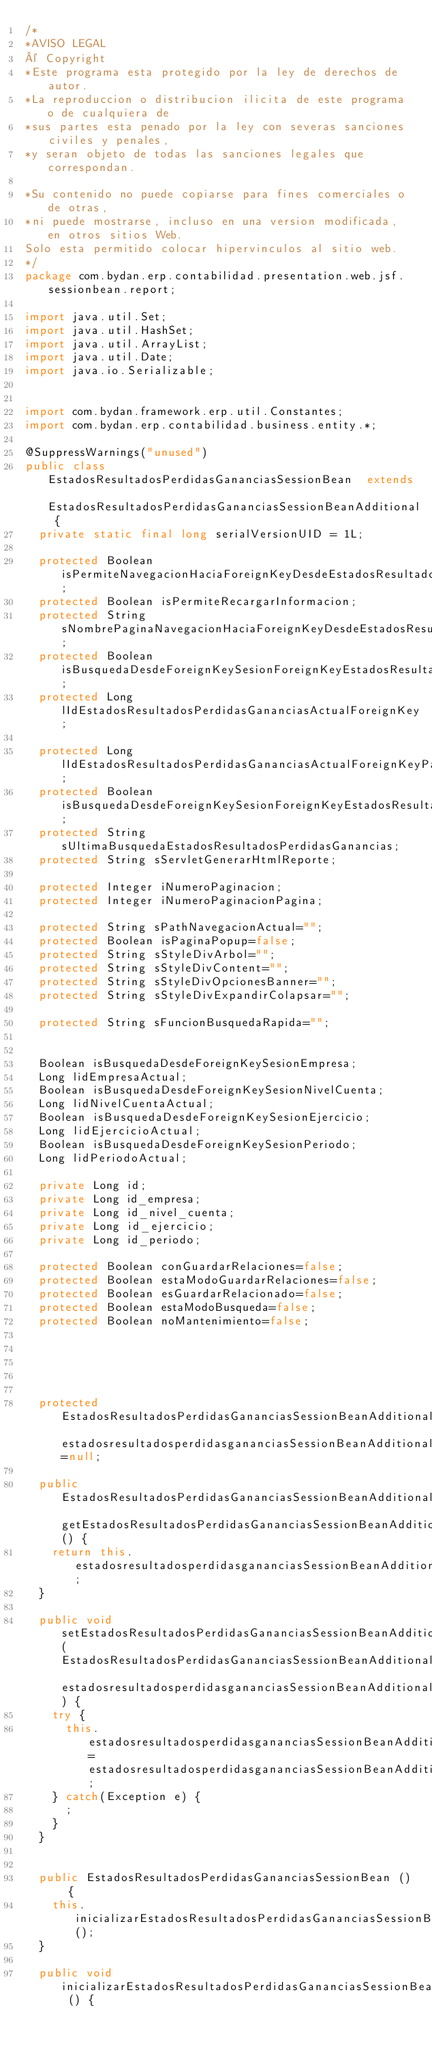Convert code to text. <code><loc_0><loc_0><loc_500><loc_500><_Java_>/*
*AVISO LEGAL
© Copyright
*Este programa esta protegido por la ley de derechos de autor.
*La reproduccion o distribucion ilicita de este programa o de cualquiera de
*sus partes esta penado por la ley con severas sanciones civiles y penales,
*y seran objeto de todas las sanciones legales que correspondan.

*Su contenido no puede copiarse para fines comerciales o de otras,
*ni puede mostrarse, incluso en una version modificada, en otros sitios Web.
Solo esta permitido colocar hipervinculos al sitio web.
*/
package com.bydan.erp.contabilidad.presentation.web.jsf.sessionbean.report;

import java.util.Set;
import java.util.HashSet;
import java.util.ArrayList;
import java.util.Date;
import java.io.Serializable;


import com.bydan.framework.erp.util.Constantes;
import com.bydan.erp.contabilidad.business.entity.*;

@SuppressWarnings("unused")
public class EstadosResultadosPerdidasGananciasSessionBean  extends EstadosResultadosPerdidasGananciasSessionBeanAdditional {
	private static final long serialVersionUID = 1L;
	
	protected Boolean isPermiteNavegacionHaciaForeignKeyDesdeEstadosResultadosPerdidasGanancias;
	protected Boolean isPermiteRecargarInformacion;
	protected String sNombrePaginaNavegacionHaciaForeignKeyDesdeEstadosResultadosPerdidasGanancias;
	protected Boolean isBusquedaDesdeForeignKeySesionForeignKeyEstadosResultadosPerdidasGanancias;
	protected Long lIdEstadosResultadosPerdidasGananciasActualForeignKey;	
	
	protected Long lIdEstadosResultadosPerdidasGananciasActualForeignKeyParaPosibleAtras;
	protected Boolean isBusquedaDesdeForeignKeySesionForeignKeyEstadosResultadosPerdidasGananciasParaPosibleAtras;
	protected String sUltimaBusquedaEstadosResultadosPerdidasGanancias;
	protected String sServletGenerarHtmlReporte;
	
	protected Integer iNumeroPaginacion;
	protected Integer iNumeroPaginacionPagina;
	
	protected String sPathNavegacionActual="";	
	protected Boolean isPaginaPopup=false;	
	protected String sStyleDivArbol="";	
	protected String sStyleDivContent="";
	protected String sStyleDivOpcionesBanner="";	
	protected String sStyleDivExpandirColapsar="";	
	
	protected String sFuncionBusquedaRapida="";
	
	
	Boolean isBusquedaDesdeForeignKeySesionEmpresa;
	Long lidEmpresaActual;
	Boolean isBusquedaDesdeForeignKeySesionNivelCuenta;
	Long lidNivelCuentaActual;
	Boolean isBusquedaDesdeForeignKeySesionEjercicio;
	Long lidEjercicioActual;
	Boolean isBusquedaDesdeForeignKeySesionPeriodo;
	Long lidPeriodoActual;
	
	private Long id;
	private Long id_empresa;
	private Long id_nivel_cuenta;
	private Long id_ejercicio;
	private Long id_periodo;
	
	protected Boolean conGuardarRelaciones=false;
	protected Boolean estaModoGuardarRelaciones=false;
	protected Boolean esGuardarRelacionado=false;
	protected Boolean estaModoBusqueda=false;
	protected Boolean noMantenimiento=false;
	
					
	 	
		
	
	protected EstadosResultadosPerdidasGananciasSessionBeanAdditional estadosresultadosperdidasgananciasSessionBeanAdditional=null;
	
	public EstadosResultadosPerdidasGananciasSessionBeanAdditional getEstadosResultadosPerdidasGananciasSessionBeanAdditional() {
		return this.estadosresultadosperdidasgananciasSessionBeanAdditional;
	}
	
	public void setEstadosResultadosPerdidasGananciasSessionBeanAdditional(EstadosResultadosPerdidasGananciasSessionBeanAdditional estadosresultadosperdidasgananciasSessionBeanAdditional) {
		try {
			this.estadosresultadosperdidasgananciasSessionBeanAdditional=estadosresultadosperdidasgananciasSessionBeanAdditional;
		} catch(Exception e) {
			;
		}
	}
	
	
	public EstadosResultadosPerdidasGananciasSessionBean () {
		this.inicializarEstadosResultadosPerdidasGananciasSessionBean();
	}
	
	public void inicializarEstadosResultadosPerdidasGananciasSessionBean () {	</code> 